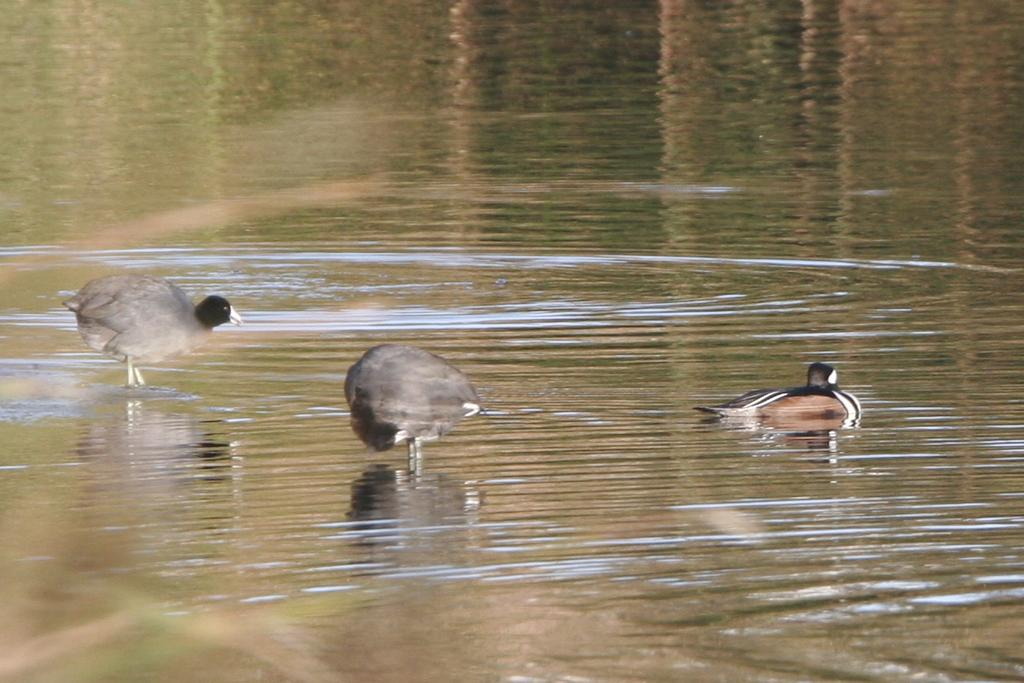How many birds are visible in the image? There are three birds in the image. Where are the birds located in the image? The birds are on the water. What type of mask is the bird wearing in the image? There is no mask present on the birds in the image. How many leaves are floating near the birds in the image? There are no leaves visible in the image; the birds are on the water. 